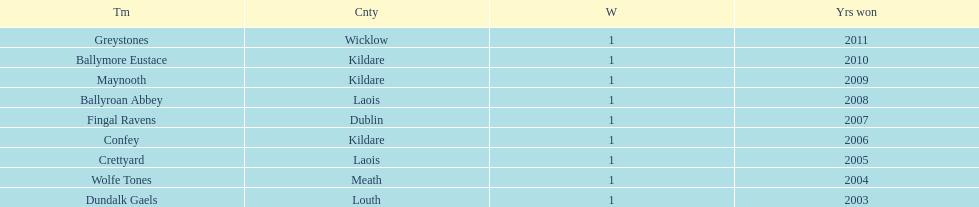Parse the full table. {'header': ['Tm', 'Cnty', 'W', 'Yrs won'], 'rows': [['Greystones', 'Wicklow', '1', '2011'], ['Ballymore Eustace', 'Kildare', '1', '2010'], ['Maynooth', 'Kildare', '1', '2009'], ['Ballyroan Abbey', 'Laois', '1', '2008'], ['Fingal Ravens', 'Dublin', '1', '2007'], ['Confey', 'Kildare', '1', '2006'], ['Crettyard', 'Laois', '1', '2005'], ['Wolfe Tones', 'Meath', '1', '2004'], ['Dundalk Gaels', 'Louth', '1', '2003']]} What is the number of wins for greystones? 1. 